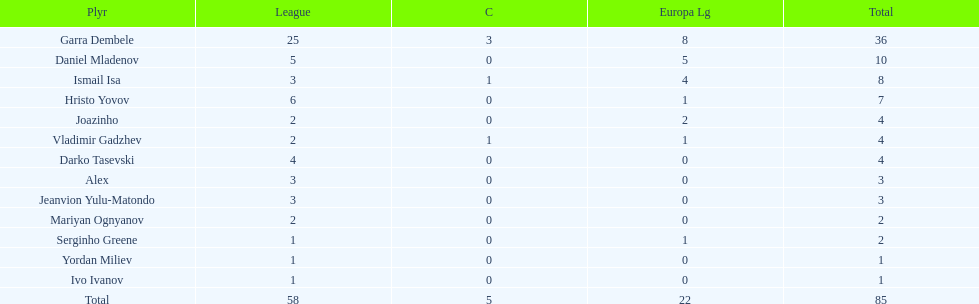Which players only scored one goal? Serginho Greene, Yordan Miliev, Ivo Ivanov. 